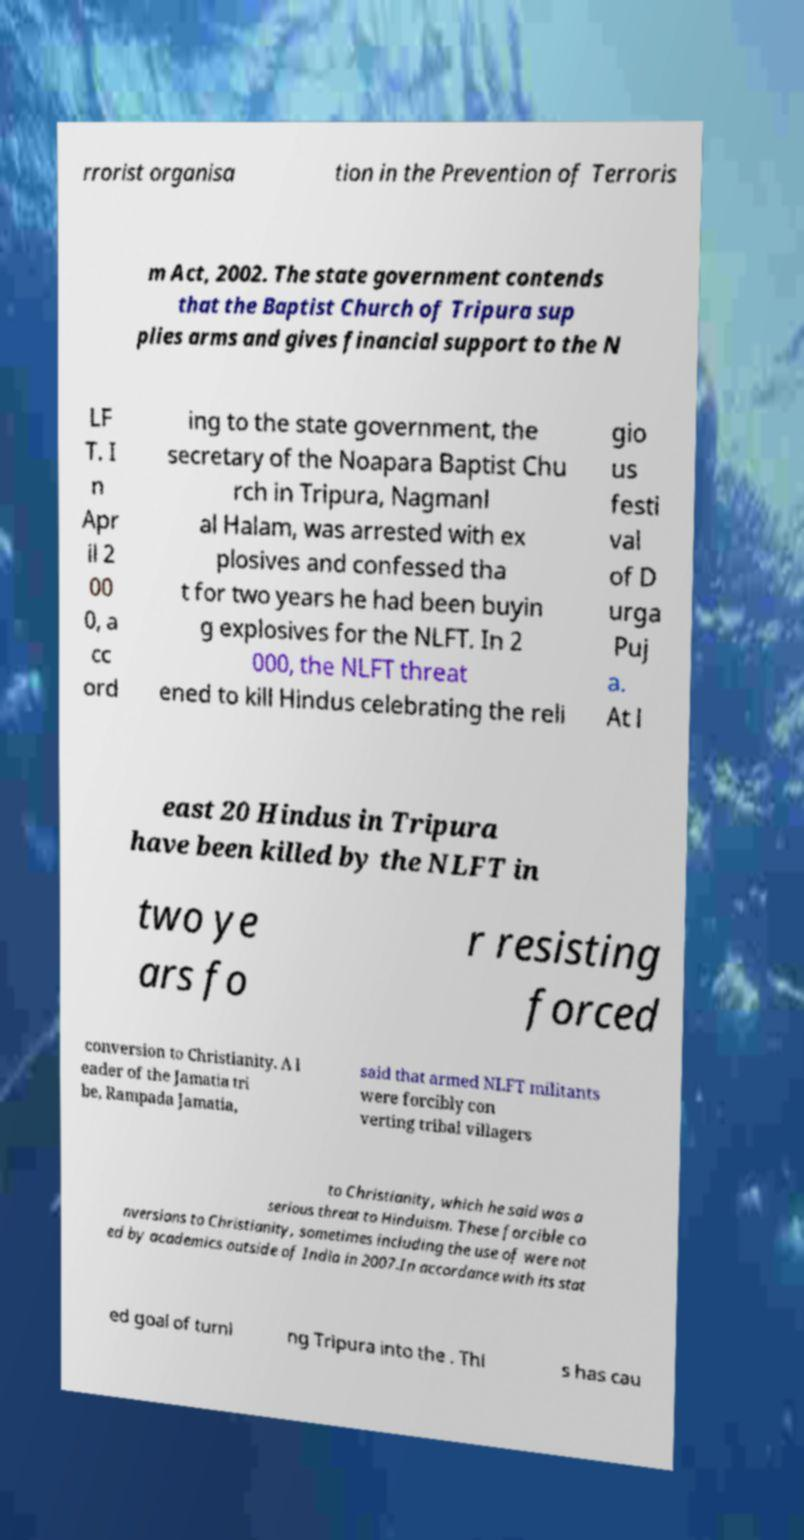Could you extract and type out the text from this image? rrorist organisa tion in the Prevention of Terroris m Act, 2002. The state government contends that the Baptist Church of Tripura sup plies arms and gives financial support to the N LF T. I n Apr il 2 00 0, a cc ord ing to the state government, the secretary of the Noapara Baptist Chu rch in Tripura, Nagmanl al Halam, was arrested with ex plosives and confessed tha t for two years he had been buyin g explosives for the NLFT. In 2 000, the NLFT threat ened to kill Hindus celebrating the reli gio us festi val of D urga Puj a. At l east 20 Hindus in Tripura have been killed by the NLFT in two ye ars fo r resisting forced conversion to Christianity. A l eader of the Jamatia tri be, Rampada Jamatia, said that armed NLFT militants were forcibly con verting tribal villagers to Christianity, which he said was a serious threat to Hinduism. These forcible co nversions to Christianity, sometimes including the use of were not ed by academics outside of India in 2007.In accordance with its stat ed goal of turni ng Tripura into the . Thi s has cau 